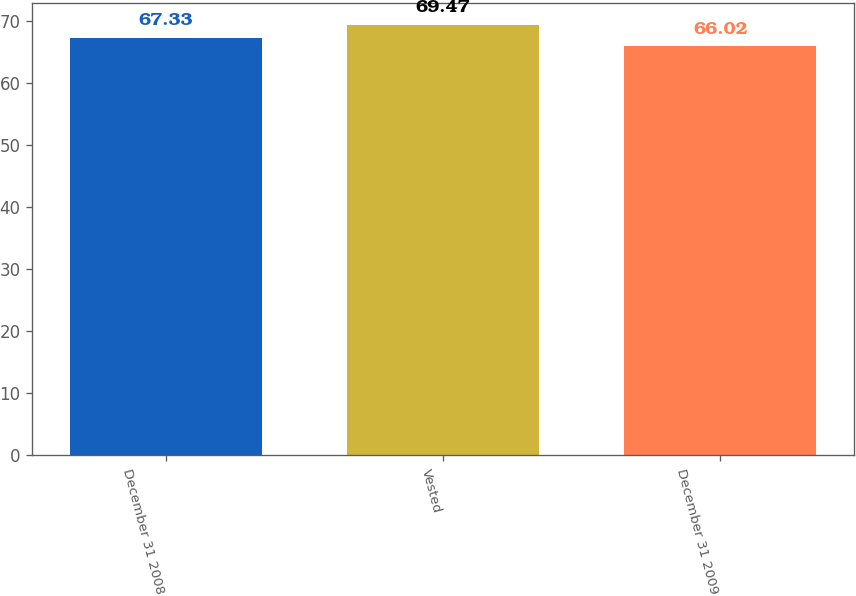<chart> <loc_0><loc_0><loc_500><loc_500><bar_chart><fcel>December 31 2008<fcel>Vested<fcel>December 31 2009<nl><fcel>67.33<fcel>69.47<fcel>66.02<nl></chart> 